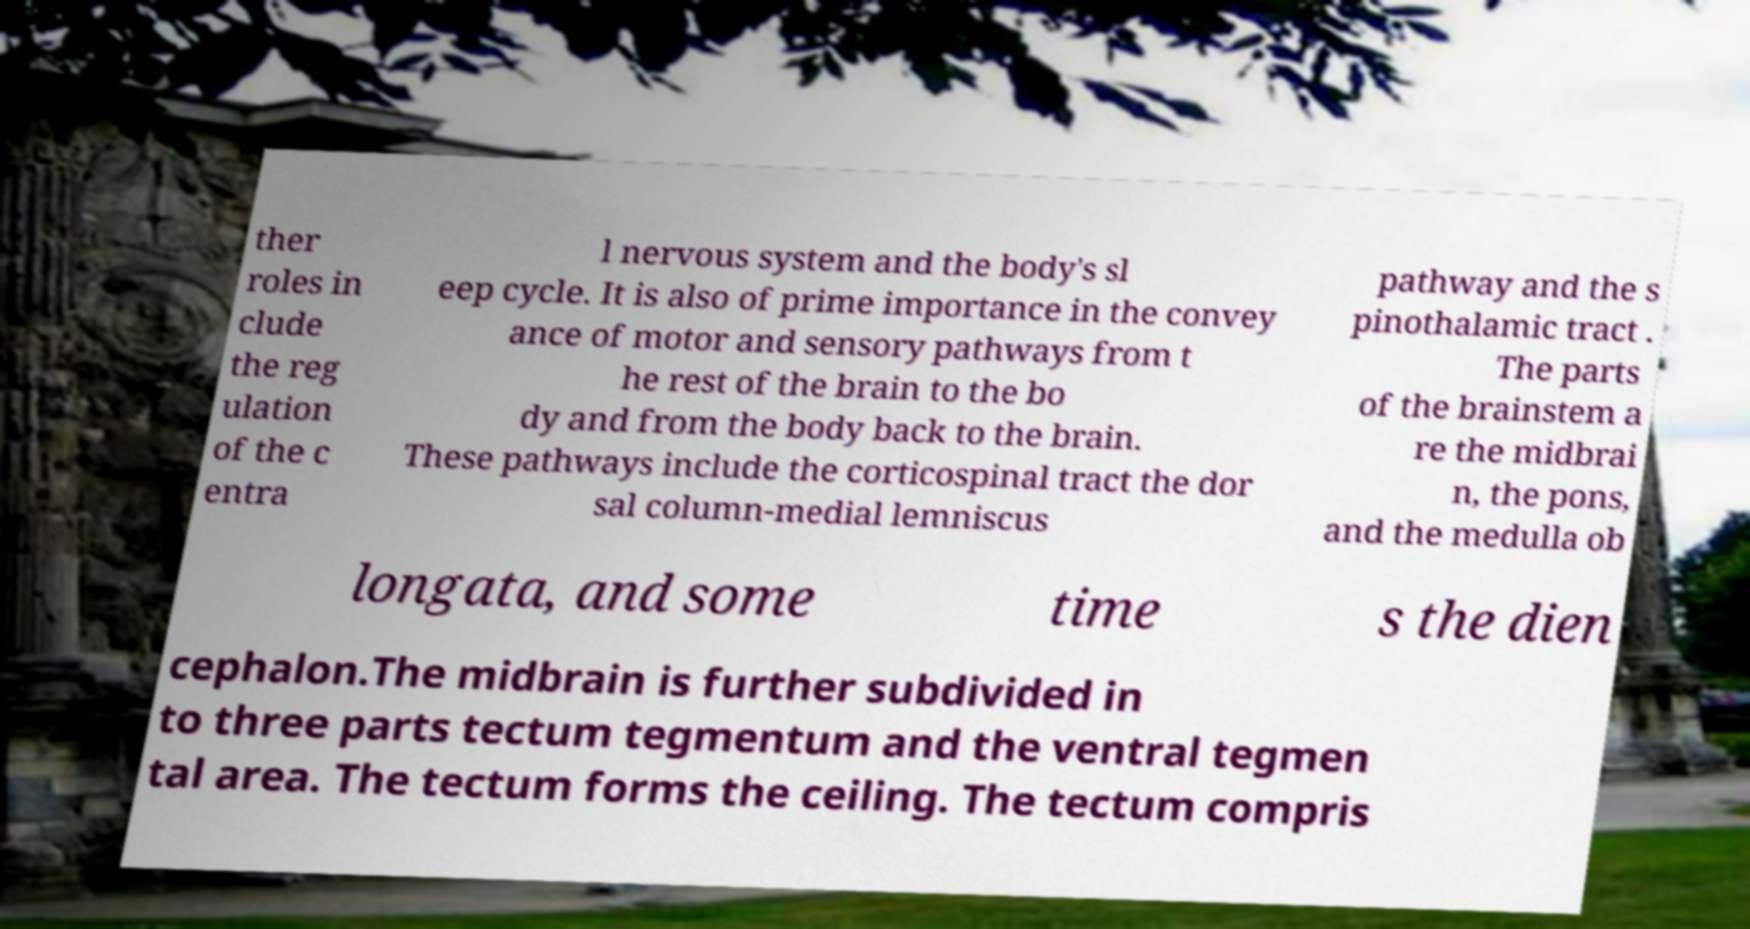Could you assist in decoding the text presented in this image and type it out clearly? ther roles in clude the reg ulation of the c entra l nervous system and the body's sl eep cycle. It is also of prime importance in the convey ance of motor and sensory pathways from t he rest of the brain to the bo dy and from the body back to the brain. These pathways include the corticospinal tract the dor sal column-medial lemniscus pathway and the s pinothalamic tract . The parts of the brainstem a re the midbrai n, the pons, and the medulla ob longata, and some time s the dien cephalon.The midbrain is further subdivided in to three parts tectum tegmentum and the ventral tegmen tal area. The tectum forms the ceiling. The tectum compris 